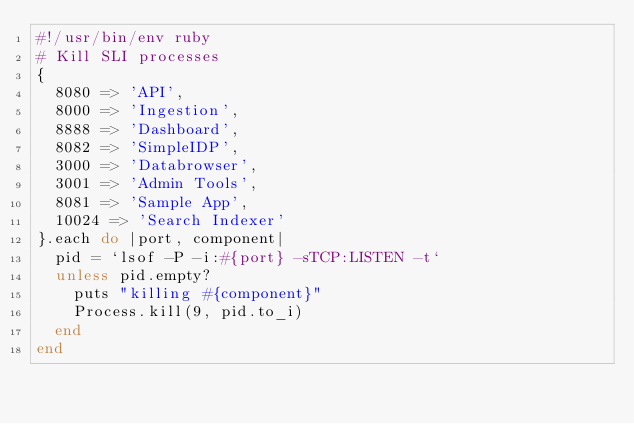Convert code to text. <code><loc_0><loc_0><loc_500><loc_500><_Ruby_>#!/usr/bin/env ruby
# Kill SLI processes
{
  8080 => 'API',
  8000 => 'Ingestion',
  8888 => 'Dashboard',
  8082 => 'SimpleIDP',
  3000 => 'Databrowser',
  3001 => 'Admin Tools',
  8081 => 'Sample App',
  10024 => 'Search Indexer'
}.each do |port, component|
  pid = `lsof -P -i:#{port} -sTCP:LISTEN -t`
  unless pid.empty?
    puts "killing #{component}"
    Process.kill(9, pid.to_i)
  end
end
</code> 